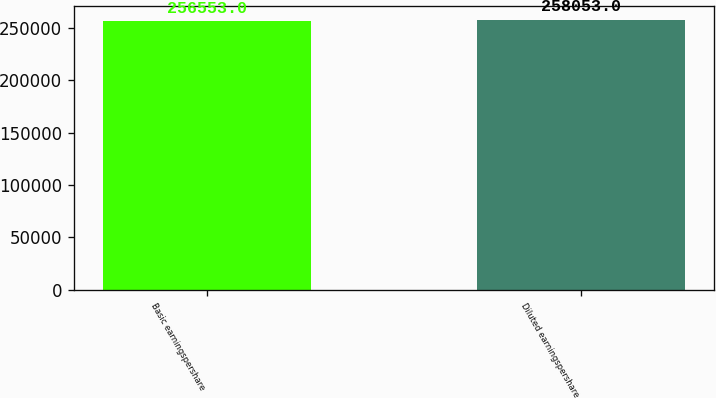Convert chart to OTSL. <chart><loc_0><loc_0><loc_500><loc_500><bar_chart><fcel>Basic earningspershare<fcel>Diluted earningspershare<nl><fcel>256553<fcel>258053<nl></chart> 